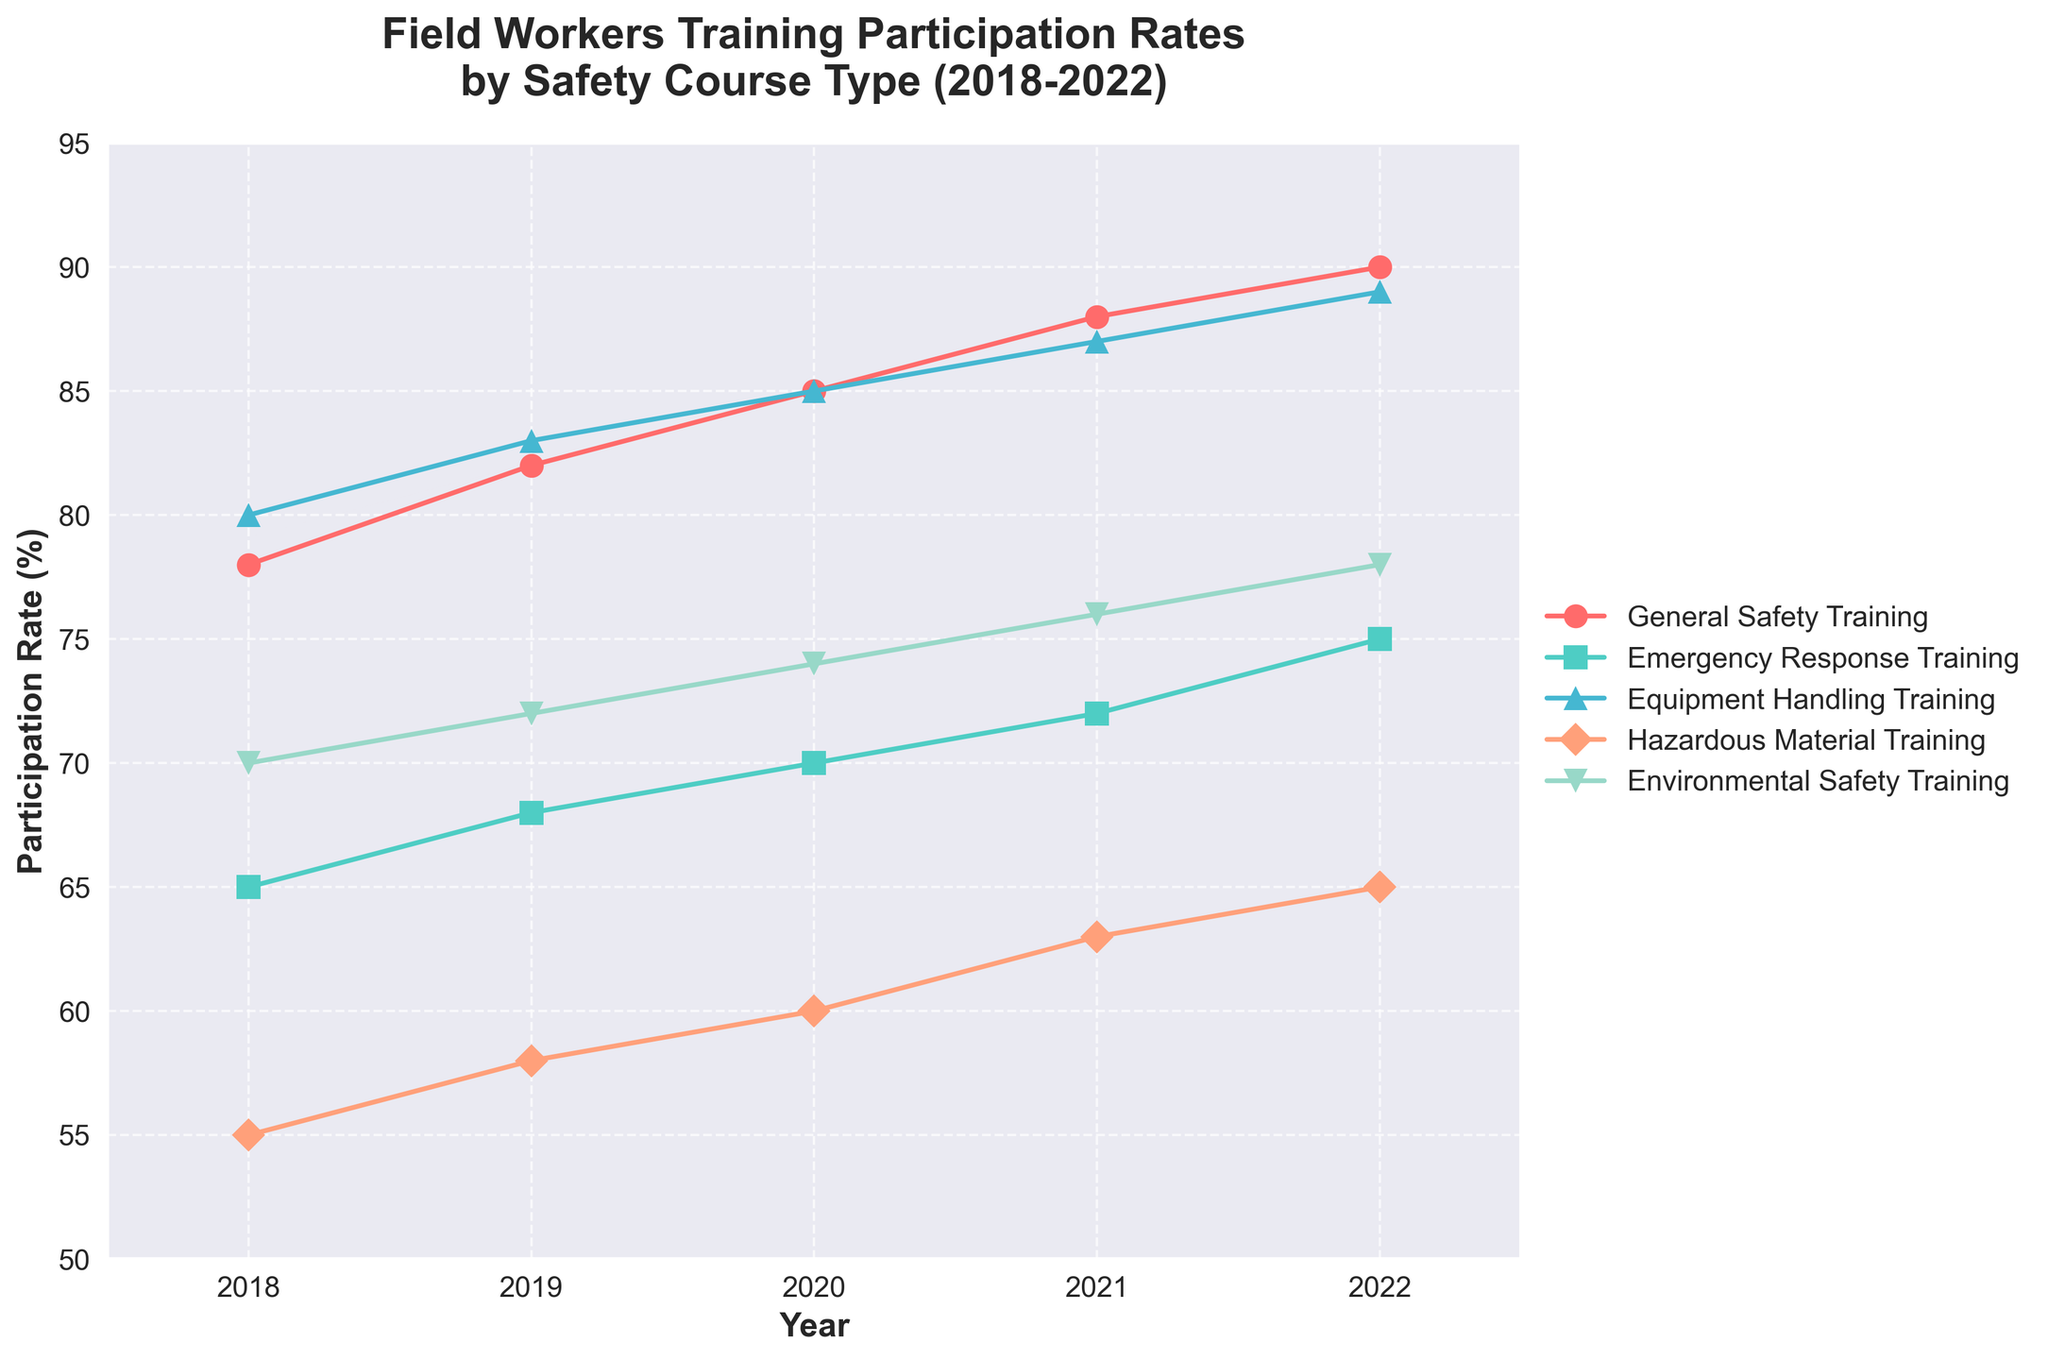What is the title of the plot? The title of the plot is usually displayed at the top of the figure. For this plot, it should read "Field Workers Training Participation Rates by Safety Course Type (2018-2022)".
Answer: Field Workers Training Participation Rates by Safety Course Type (2018-2022) Which safety course had the highest participation rate in 2018? According to the data presented, you can visually identify the course with the highest rate by looking at the highest point on the y-axis for the year 2018. General Safety Training, shown with higher y-axis value than others in 2018, had the highest rate at 80%.
Answer: Equipment Handling Training How has the participation rate for Emergency Response Training changed from 2018 to 2022? To determine this, refer to the line representing Emergency Response Training and look for its values in the years 2018 and 2022. In 2018, it is at 65%, and in 2022, it has increased to 75%.
Answer: Increased by 10% Between which consecutive years did General Safety Training see the largest increase in participation rate? To find the largest increase, we need to check the differences year-to-year for General Safety Training's participation rates: from 2018 to 2019 (4%), 2019 to 2020 (3%), 2020 to 2021 (3%), 2021 to 2022 (2%). The largest increase, 4%, was from 2018 to 2019.
Answer: 2018 to 2019 What was the participation rate for Hazardous Material Training in 2021? Locate the year 2021 on the x-axis, then find the corresponding value on the y-axis for the line that represents Hazardous Material Training, which is colored and marked as per the legend. The value is 63%.
Answer: 63% Which course had the lowest participation rate in 2022? By comparing the y-values for each course in 2022, you can note that Hazardous Material Training, at 65%, is the lowest among the other courses listed.
Answer: Hazardous Material Training What is the average participation rate of Environmental Safety Training over the five years? Sum the Environmental Safety Training rates for all years (70 + 72 + 74 + 76 + 78) resulting in 370, then divide by 5 to get the average (370/5).
Answer: 74% Among the given training courses, which one experienced the overall highest increase in participation rate from 2018 to 2022? Calculate the increase for each course from 2018 to 2022, then compare them. General Safety Training increased by 12%, Emergency Response Training by 10%, Equipment Handling Training by 9%, Hazardous Material Training by 10%, and Environmental Safety Training by 8%. General Safety Training experienced the largest increase.
Answer: General Safety Training Is there any course whose participation rate increased uniformly over the five years without any decrease? Examine each course's line on the plot to see if they steadily increased each year without any drop. General Safety Training, Emergency Response Training, Equipment Handling Training, Hazardous Material Training, and Environmental Safety Training all increased each year, so no course saw a decrease within the given years.
Answer: No 